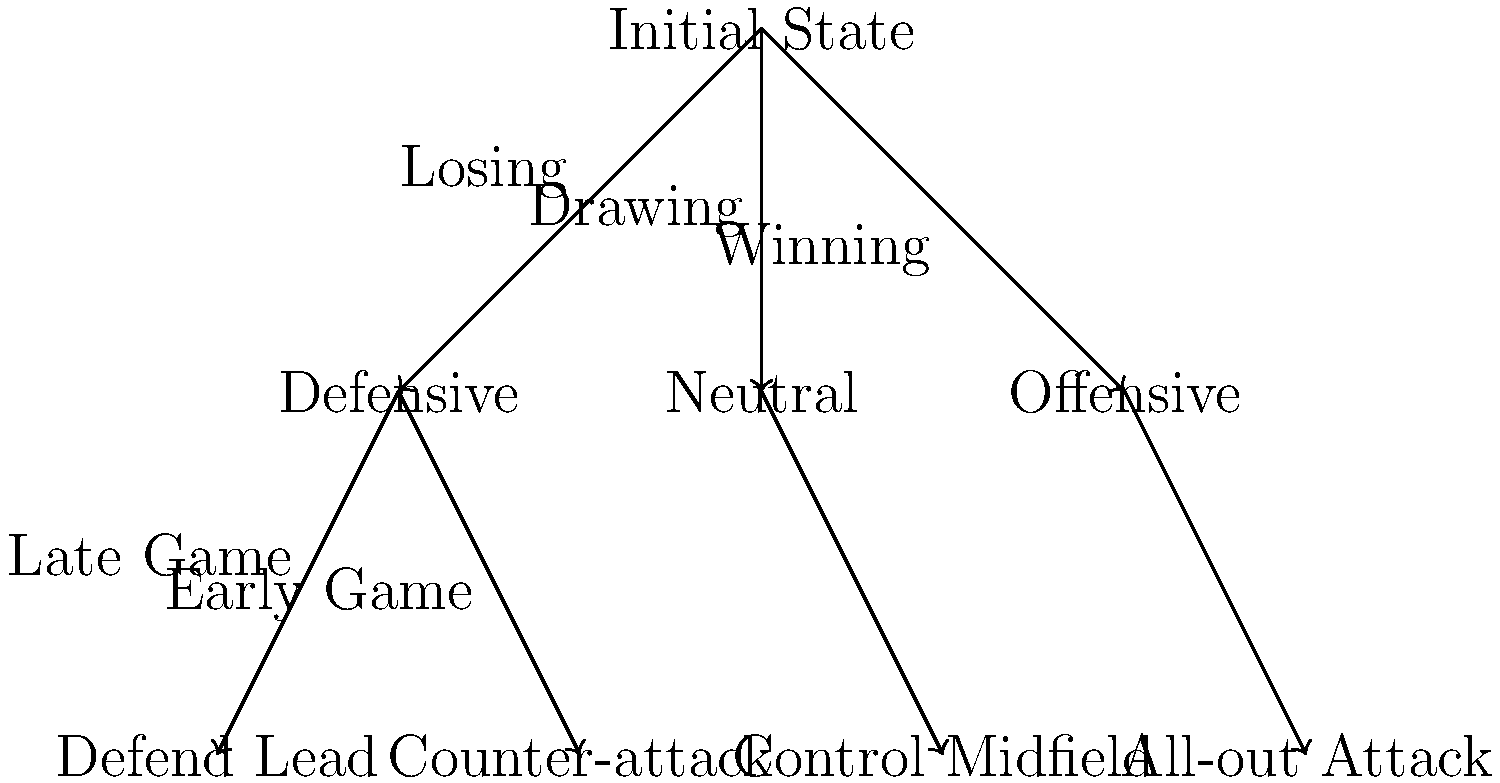In the decision tree for in-game substitution strategies, which path would a manager most likely follow if their team is winning and they want to maintain control of the game? To determine the most likely path for a manager whose team is winning and wants to maintain control of the game, let's analyze the decision tree step-by-step:

1. The initial state is at the top of the tree.

2. From the initial state, there are three branches: "Losing", "Drawing", and "Winning".
   Since the team is winning, we follow the "Winning" branch to the right.

3. The "Winning" branch leads to the "Offensive" node, which represents a generally offensive stance.

4. From the "Offensive" node, there are two potential strategies:
   a) "Control Midfield"
   b) "All-out Attack"

5. Given that the manager wants to maintain control of the game, the "Control Midfield" strategy is more appropriate. This approach allows the team to keep possession, manage the tempo, and protect their lead without taking unnecessary risks.

6. The "All-out Attack" strategy would be too aggressive and risky when the team is already winning and wants to maintain control.

Therefore, the path that a manager would most likely follow in this scenario is:
Initial State → Winning → Offensive → Control Midfield
Answer: Initial State → Winning → Offensive → Control Midfield 